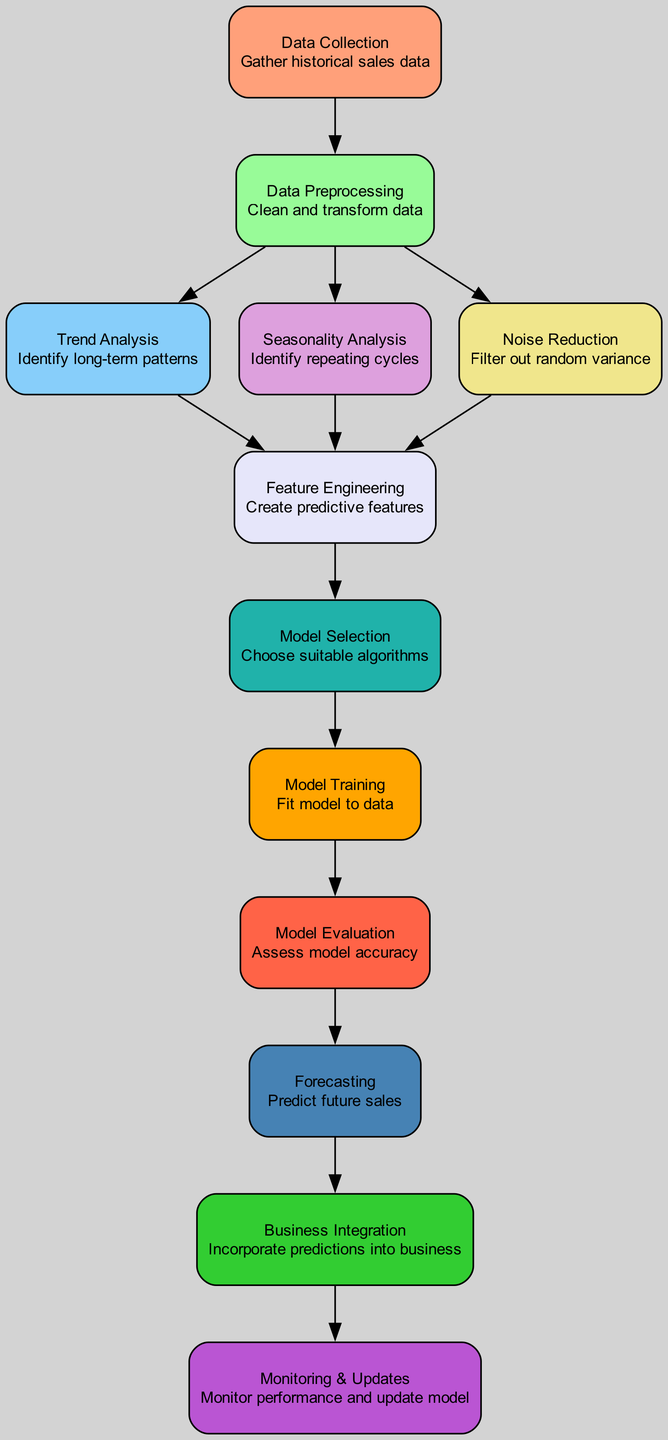What is the first step in the diagram? The first node in the diagram is labeled "Data Collection," which indicates that the initial step involves gathering historical sales data.
Answer: Data Collection How many nodes are in the diagram? By counting the different labeled components in the diagram, we can identify that there are twelve nodes, each representing a distinct step in the sales forecasting process.
Answer: Twelve What is the final step before Business Integration? The final process before "Business Integration" is "Forecasting," indicating that predictions must be made before these results can be used in business operations.
Answer: Forecasting Which three analyses are performed after Data Preprocessing? After "Data Preprocessing," three analyses occur: "Trend Analysis," "Seasonality Analysis," and "Noise Reduction," which sequentially process the cleansed data to extract patterns.
Answer: Trend Analysis, Seasonality Analysis, Noise Reduction What connects Model Selection to Model Training? There is a directed edge that connects "Model Selection" to "Model Training," indicating that after selecting suitable algorithms, those algorithms are then used for training the model.
Answer: Directed edge What is the relationship between Feature Engineering and Trend, Seasonality, and Noise components? "Feature Engineering" builds predictive features based upon the insights derived from "Trend Analysis," "Seasonality Analysis," and "Noise Reduction." Thus, these three components influence the features created.
Answer: Influence on features How does Monitoring & Updates relate to Business Integration? "Monitoring & Updates" follows "Business Integration," suggesting that once predictions are integrated into the business processes, continuous monitoring and updates of the model are essential to maintain its accuracy over time.
Answer: Continuous monitoring and updates Which component is primarily focused on predicting future sales? The component "Forecasting" is specifically designated for predicting future sales based on the processed data and trained model.
Answer: Forecasting What is the primary purpose of Noise Reduction in the diagram? The "Noise Reduction" step aims to filter out random variance in the sales data, ensuring that the model is trained on more reliable signals rather than on fluctuations that do not reflect true sales trends.
Answer: Filter out random variance 